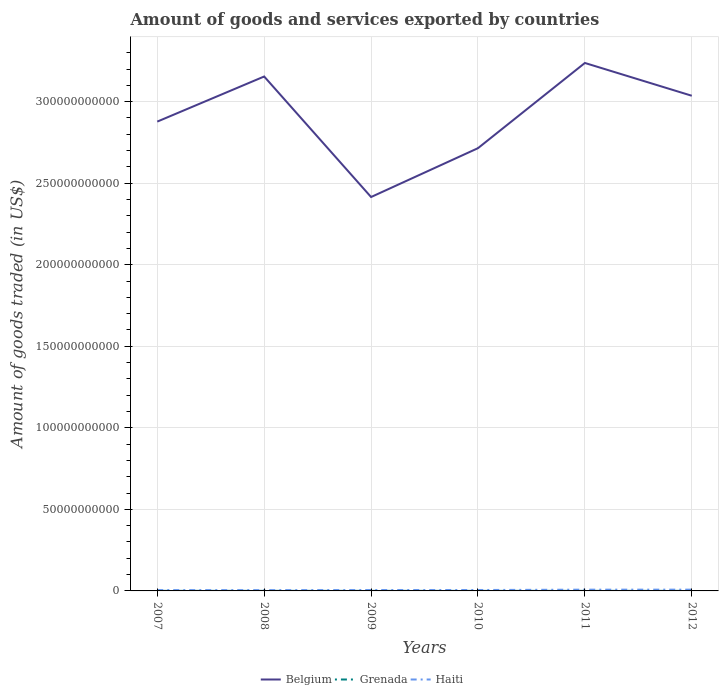How many different coloured lines are there?
Give a very brief answer. 3. Is the number of lines equal to the number of legend labels?
Make the answer very short. Yes. Across all years, what is the maximum total amount of goods and services exported in Grenada?
Provide a short and direct response. 3.11e+07. In which year was the total amount of goods and services exported in Haiti maximum?
Ensure brevity in your answer.  2008. What is the total total amount of goods and services exported in Haiti in the graph?
Your answer should be compact. -2.78e+08. What is the difference between the highest and the second highest total amount of goods and services exported in Belgium?
Offer a terse response. 8.22e+1. What is the difference between the highest and the lowest total amount of goods and services exported in Belgium?
Provide a short and direct response. 3. Is the total amount of goods and services exported in Belgium strictly greater than the total amount of goods and services exported in Grenada over the years?
Ensure brevity in your answer.  No. How many lines are there?
Ensure brevity in your answer.  3. How many years are there in the graph?
Make the answer very short. 6. How many legend labels are there?
Offer a terse response. 3. What is the title of the graph?
Your response must be concise. Amount of goods and services exported by countries. Does "Arab World" appear as one of the legend labels in the graph?
Your response must be concise. No. What is the label or title of the X-axis?
Offer a very short reply. Years. What is the label or title of the Y-axis?
Make the answer very short. Amount of goods traded (in US$). What is the Amount of goods traded (in US$) in Belgium in 2007?
Offer a very short reply. 2.88e+11. What is the Amount of goods traded (in US$) of Grenada in 2007?
Your response must be concise. 4.07e+07. What is the Amount of goods traded (in US$) of Haiti in 2007?
Ensure brevity in your answer.  5.22e+08. What is the Amount of goods traded (in US$) in Belgium in 2008?
Keep it short and to the point. 3.15e+11. What is the Amount of goods traded (in US$) of Grenada in 2008?
Provide a succinct answer. 4.05e+07. What is the Amount of goods traded (in US$) of Haiti in 2008?
Make the answer very short. 4.90e+08. What is the Amount of goods traded (in US$) of Belgium in 2009?
Give a very brief answer. 2.42e+11. What is the Amount of goods traded (in US$) of Grenada in 2009?
Your response must be concise. 3.53e+07. What is the Amount of goods traded (in US$) of Haiti in 2009?
Provide a succinct answer. 5.51e+08. What is the Amount of goods traded (in US$) of Belgium in 2010?
Your response must be concise. 2.71e+11. What is the Amount of goods traded (in US$) of Grenada in 2010?
Offer a terse response. 3.11e+07. What is the Amount of goods traded (in US$) of Haiti in 2010?
Offer a terse response. 5.63e+08. What is the Amount of goods traded (in US$) in Belgium in 2011?
Your answer should be compact. 3.24e+11. What is the Amount of goods traded (in US$) of Grenada in 2011?
Give a very brief answer. 3.72e+07. What is the Amount of goods traded (in US$) in Haiti in 2011?
Offer a very short reply. 7.68e+08. What is the Amount of goods traded (in US$) in Belgium in 2012?
Offer a very short reply. 3.04e+11. What is the Amount of goods traded (in US$) of Grenada in 2012?
Offer a terse response. 4.28e+07. What is the Amount of goods traded (in US$) of Haiti in 2012?
Make the answer very short. 7.79e+08. Across all years, what is the maximum Amount of goods traded (in US$) in Belgium?
Give a very brief answer. 3.24e+11. Across all years, what is the maximum Amount of goods traded (in US$) of Grenada?
Ensure brevity in your answer.  4.28e+07. Across all years, what is the maximum Amount of goods traded (in US$) of Haiti?
Ensure brevity in your answer.  7.79e+08. Across all years, what is the minimum Amount of goods traded (in US$) of Belgium?
Your answer should be compact. 2.42e+11. Across all years, what is the minimum Amount of goods traded (in US$) in Grenada?
Your response must be concise. 3.11e+07. Across all years, what is the minimum Amount of goods traded (in US$) in Haiti?
Provide a short and direct response. 4.90e+08. What is the total Amount of goods traded (in US$) of Belgium in the graph?
Offer a terse response. 1.74e+12. What is the total Amount of goods traded (in US$) in Grenada in the graph?
Your answer should be very brief. 2.28e+08. What is the total Amount of goods traded (in US$) in Haiti in the graph?
Your response must be concise. 3.67e+09. What is the difference between the Amount of goods traded (in US$) of Belgium in 2007 and that in 2008?
Provide a short and direct response. -2.77e+1. What is the difference between the Amount of goods traded (in US$) in Grenada in 2007 and that in 2008?
Your answer should be very brief. 2.65e+05. What is the difference between the Amount of goods traded (in US$) in Haiti in 2007 and that in 2008?
Provide a short and direct response. 3.19e+07. What is the difference between the Amount of goods traded (in US$) in Belgium in 2007 and that in 2009?
Provide a succinct answer. 4.62e+1. What is the difference between the Amount of goods traded (in US$) in Grenada in 2007 and that in 2009?
Provide a short and direct response. 5.44e+06. What is the difference between the Amount of goods traded (in US$) in Haiti in 2007 and that in 2009?
Offer a terse response. -2.89e+07. What is the difference between the Amount of goods traded (in US$) of Belgium in 2007 and that in 2010?
Give a very brief answer. 1.63e+1. What is the difference between the Amount of goods traded (in US$) of Grenada in 2007 and that in 2010?
Your answer should be compact. 9.61e+06. What is the difference between the Amount of goods traded (in US$) in Haiti in 2007 and that in 2010?
Keep it short and to the point. -4.13e+07. What is the difference between the Amount of goods traded (in US$) in Belgium in 2007 and that in 2011?
Give a very brief answer. -3.60e+1. What is the difference between the Amount of goods traded (in US$) of Grenada in 2007 and that in 2011?
Your answer should be compact. 3.58e+06. What is the difference between the Amount of goods traded (in US$) in Haiti in 2007 and that in 2011?
Keep it short and to the point. -2.46e+08. What is the difference between the Amount of goods traded (in US$) of Belgium in 2007 and that in 2012?
Your answer should be compact. -1.59e+1. What is the difference between the Amount of goods traded (in US$) of Grenada in 2007 and that in 2012?
Make the answer very short. -2.08e+06. What is the difference between the Amount of goods traded (in US$) of Haiti in 2007 and that in 2012?
Offer a very short reply. -2.57e+08. What is the difference between the Amount of goods traded (in US$) in Belgium in 2008 and that in 2009?
Keep it short and to the point. 7.39e+1. What is the difference between the Amount of goods traded (in US$) of Grenada in 2008 and that in 2009?
Offer a very short reply. 5.17e+06. What is the difference between the Amount of goods traded (in US$) of Haiti in 2008 and that in 2009?
Provide a succinct answer. -6.08e+07. What is the difference between the Amount of goods traded (in US$) in Belgium in 2008 and that in 2010?
Provide a short and direct response. 4.40e+1. What is the difference between the Amount of goods traded (in US$) of Grenada in 2008 and that in 2010?
Your answer should be compact. 9.34e+06. What is the difference between the Amount of goods traded (in US$) in Haiti in 2008 and that in 2010?
Your response must be concise. -7.32e+07. What is the difference between the Amount of goods traded (in US$) in Belgium in 2008 and that in 2011?
Keep it short and to the point. -8.30e+09. What is the difference between the Amount of goods traded (in US$) of Grenada in 2008 and that in 2011?
Offer a very short reply. 3.31e+06. What is the difference between the Amount of goods traded (in US$) of Haiti in 2008 and that in 2011?
Give a very brief answer. -2.78e+08. What is the difference between the Amount of goods traded (in US$) in Belgium in 2008 and that in 2012?
Make the answer very short. 1.18e+1. What is the difference between the Amount of goods traded (in US$) of Grenada in 2008 and that in 2012?
Give a very brief answer. -2.35e+06. What is the difference between the Amount of goods traded (in US$) in Haiti in 2008 and that in 2012?
Make the answer very short. -2.89e+08. What is the difference between the Amount of goods traded (in US$) of Belgium in 2009 and that in 2010?
Your answer should be compact. -3.00e+1. What is the difference between the Amount of goods traded (in US$) of Grenada in 2009 and that in 2010?
Make the answer very short. 4.17e+06. What is the difference between the Amount of goods traded (in US$) in Haiti in 2009 and that in 2010?
Your answer should be compact. -1.24e+07. What is the difference between the Amount of goods traded (in US$) in Belgium in 2009 and that in 2011?
Your answer should be very brief. -8.22e+1. What is the difference between the Amount of goods traded (in US$) of Grenada in 2009 and that in 2011?
Your response must be concise. -1.86e+06. What is the difference between the Amount of goods traded (in US$) in Haiti in 2009 and that in 2011?
Give a very brief answer. -2.17e+08. What is the difference between the Amount of goods traded (in US$) of Belgium in 2009 and that in 2012?
Provide a short and direct response. -6.21e+1. What is the difference between the Amount of goods traded (in US$) in Grenada in 2009 and that in 2012?
Provide a succinct answer. -7.52e+06. What is the difference between the Amount of goods traded (in US$) in Haiti in 2009 and that in 2012?
Keep it short and to the point. -2.28e+08. What is the difference between the Amount of goods traded (in US$) of Belgium in 2010 and that in 2011?
Offer a terse response. -5.22e+1. What is the difference between the Amount of goods traded (in US$) of Grenada in 2010 and that in 2011?
Your answer should be very brief. -6.03e+06. What is the difference between the Amount of goods traded (in US$) of Haiti in 2010 and that in 2011?
Your answer should be compact. -2.05e+08. What is the difference between the Amount of goods traded (in US$) of Belgium in 2010 and that in 2012?
Your answer should be compact. -3.22e+1. What is the difference between the Amount of goods traded (in US$) in Grenada in 2010 and that in 2012?
Keep it short and to the point. -1.17e+07. What is the difference between the Amount of goods traded (in US$) in Haiti in 2010 and that in 2012?
Provide a short and direct response. -2.15e+08. What is the difference between the Amount of goods traded (in US$) in Belgium in 2011 and that in 2012?
Your answer should be compact. 2.01e+1. What is the difference between the Amount of goods traded (in US$) of Grenada in 2011 and that in 2012?
Your answer should be compact. -5.66e+06. What is the difference between the Amount of goods traded (in US$) in Haiti in 2011 and that in 2012?
Provide a short and direct response. -1.08e+07. What is the difference between the Amount of goods traded (in US$) in Belgium in 2007 and the Amount of goods traded (in US$) in Grenada in 2008?
Keep it short and to the point. 2.88e+11. What is the difference between the Amount of goods traded (in US$) in Belgium in 2007 and the Amount of goods traded (in US$) in Haiti in 2008?
Your answer should be very brief. 2.87e+11. What is the difference between the Amount of goods traded (in US$) of Grenada in 2007 and the Amount of goods traded (in US$) of Haiti in 2008?
Keep it short and to the point. -4.49e+08. What is the difference between the Amount of goods traded (in US$) of Belgium in 2007 and the Amount of goods traded (in US$) of Grenada in 2009?
Your response must be concise. 2.88e+11. What is the difference between the Amount of goods traded (in US$) in Belgium in 2007 and the Amount of goods traded (in US$) in Haiti in 2009?
Keep it short and to the point. 2.87e+11. What is the difference between the Amount of goods traded (in US$) of Grenada in 2007 and the Amount of goods traded (in US$) of Haiti in 2009?
Ensure brevity in your answer.  -5.10e+08. What is the difference between the Amount of goods traded (in US$) of Belgium in 2007 and the Amount of goods traded (in US$) of Grenada in 2010?
Offer a terse response. 2.88e+11. What is the difference between the Amount of goods traded (in US$) in Belgium in 2007 and the Amount of goods traded (in US$) in Haiti in 2010?
Your answer should be very brief. 2.87e+11. What is the difference between the Amount of goods traded (in US$) in Grenada in 2007 and the Amount of goods traded (in US$) in Haiti in 2010?
Ensure brevity in your answer.  -5.23e+08. What is the difference between the Amount of goods traded (in US$) in Belgium in 2007 and the Amount of goods traded (in US$) in Grenada in 2011?
Your answer should be very brief. 2.88e+11. What is the difference between the Amount of goods traded (in US$) in Belgium in 2007 and the Amount of goods traded (in US$) in Haiti in 2011?
Your response must be concise. 2.87e+11. What is the difference between the Amount of goods traded (in US$) in Grenada in 2007 and the Amount of goods traded (in US$) in Haiti in 2011?
Keep it short and to the point. -7.27e+08. What is the difference between the Amount of goods traded (in US$) of Belgium in 2007 and the Amount of goods traded (in US$) of Grenada in 2012?
Your answer should be compact. 2.88e+11. What is the difference between the Amount of goods traded (in US$) of Belgium in 2007 and the Amount of goods traded (in US$) of Haiti in 2012?
Your answer should be very brief. 2.87e+11. What is the difference between the Amount of goods traded (in US$) in Grenada in 2007 and the Amount of goods traded (in US$) in Haiti in 2012?
Ensure brevity in your answer.  -7.38e+08. What is the difference between the Amount of goods traded (in US$) of Belgium in 2008 and the Amount of goods traded (in US$) of Grenada in 2009?
Your answer should be compact. 3.15e+11. What is the difference between the Amount of goods traded (in US$) in Belgium in 2008 and the Amount of goods traded (in US$) in Haiti in 2009?
Give a very brief answer. 3.15e+11. What is the difference between the Amount of goods traded (in US$) in Grenada in 2008 and the Amount of goods traded (in US$) in Haiti in 2009?
Give a very brief answer. -5.11e+08. What is the difference between the Amount of goods traded (in US$) of Belgium in 2008 and the Amount of goods traded (in US$) of Grenada in 2010?
Keep it short and to the point. 3.15e+11. What is the difference between the Amount of goods traded (in US$) of Belgium in 2008 and the Amount of goods traded (in US$) of Haiti in 2010?
Provide a short and direct response. 3.15e+11. What is the difference between the Amount of goods traded (in US$) in Grenada in 2008 and the Amount of goods traded (in US$) in Haiti in 2010?
Provide a succinct answer. -5.23e+08. What is the difference between the Amount of goods traded (in US$) in Belgium in 2008 and the Amount of goods traded (in US$) in Grenada in 2011?
Provide a succinct answer. 3.15e+11. What is the difference between the Amount of goods traded (in US$) in Belgium in 2008 and the Amount of goods traded (in US$) in Haiti in 2011?
Give a very brief answer. 3.15e+11. What is the difference between the Amount of goods traded (in US$) of Grenada in 2008 and the Amount of goods traded (in US$) of Haiti in 2011?
Offer a terse response. -7.28e+08. What is the difference between the Amount of goods traded (in US$) in Belgium in 2008 and the Amount of goods traded (in US$) in Grenada in 2012?
Give a very brief answer. 3.15e+11. What is the difference between the Amount of goods traded (in US$) of Belgium in 2008 and the Amount of goods traded (in US$) of Haiti in 2012?
Provide a short and direct response. 3.15e+11. What is the difference between the Amount of goods traded (in US$) of Grenada in 2008 and the Amount of goods traded (in US$) of Haiti in 2012?
Your answer should be very brief. -7.38e+08. What is the difference between the Amount of goods traded (in US$) of Belgium in 2009 and the Amount of goods traded (in US$) of Grenada in 2010?
Provide a short and direct response. 2.41e+11. What is the difference between the Amount of goods traded (in US$) of Belgium in 2009 and the Amount of goods traded (in US$) of Haiti in 2010?
Offer a very short reply. 2.41e+11. What is the difference between the Amount of goods traded (in US$) in Grenada in 2009 and the Amount of goods traded (in US$) in Haiti in 2010?
Offer a very short reply. -5.28e+08. What is the difference between the Amount of goods traded (in US$) of Belgium in 2009 and the Amount of goods traded (in US$) of Grenada in 2011?
Offer a very short reply. 2.41e+11. What is the difference between the Amount of goods traded (in US$) in Belgium in 2009 and the Amount of goods traded (in US$) in Haiti in 2011?
Your answer should be very brief. 2.41e+11. What is the difference between the Amount of goods traded (in US$) in Grenada in 2009 and the Amount of goods traded (in US$) in Haiti in 2011?
Make the answer very short. -7.33e+08. What is the difference between the Amount of goods traded (in US$) of Belgium in 2009 and the Amount of goods traded (in US$) of Grenada in 2012?
Your response must be concise. 2.41e+11. What is the difference between the Amount of goods traded (in US$) of Belgium in 2009 and the Amount of goods traded (in US$) of Haiti in 2012?
Offer a terse response. 2.41e+11. What is the difference between the Amount of goods traded (in US$) in Grenada in 2009 and the Amount of goods traded (in US$) in Haiti in 2012?
Keep it short and to the point. -7.44e+08. What is the difference between the Amount of goods traded (in US$) in Belgium in 2010 and the Amount of goods traded (in US$) in Grenada in 2011?
Offer a terse response. 2.71e+11. What is the difference between the Amount of goods traded (in US$) of Belgium in 2010 and the Amount of goods traded (in US$) of Haiti in 2011?
Your answer should be compact. 2.71e+11. What is the difference between the Amount of goods traded (in US$) in Grenada in 2010 and the Amount of goods traded (in US$) in Haiti in 2011?
Offer a very short reply. -7.37e+08. What is the difference between the Amount of goods traded (in US$) of Belgium in 2010 and the Amount of goods traded (in US$) of Grenada in 2012?
Ensure brevity in your answer.  2.71e+11. What is the difference between the Amount of goods traded (in US$) in Belgium in 2010 and the Amount of goods traded (in US$) in Haiti in 2012?
Your answer should be compact. 2.71e+11. What is the difference between the Amount of goods traded (in US$) of Grenada in 2010 and the Amount of goods traded (in US$) of Haiti in 2012?
Your answer should be compact. -7.48e+08. What is the difference between the Amount of goods traded (in US$) in Belgium in 2011 and the Amount of goods traded (in US$) in Grenada in 2012?
Offer a terse response. 3.24e+11. What is the difference between the Amount of goods traded (in US$) of Belgium in 2011 and the Amount of goods traded (in US$) of Haiti in 2012?
Your answer should be very brief. 3.23e+11. What is the difference between the Amount of goods traded (in US$) of Grenada in 2011 and the Amount of goods traded (in US$) of Haiti in 2012?
Make the answer very short. -7.42e+08. What is the average Amount of goods traded (in US$) of Belgium per year?
Give a very brief answer. 2.91e+11. What is the average Amount of goods traded (in US$) of Grenada per year?
Keep it short and to the point. 3.79e+07. What is the average Amount of goods traded (in US$) in Haiti per year?
Offer a terse response. 6.12e+08. In the year 2007, what is the difference between the Amount of goods traded (in US$) in Belgium and Amount of goods traded (in US$) in Grenada?
Your response must be concise. 2.88e+11. In the year 2007, what is the difference between the Amount of goods traded (in US$) of Belgium and Amount of goods traded (in US$) of Haiti?
Your answer should be compact. 2.87e+11. In the year 2007, what is the difference between the Amount of goods traded (in US$) of Grenada and Amount of goods traded (in US$) of Haiti?
Ensure brevity in your answer.  -4.81e+08. In the year 2008, what is the difference between the Amount of goods traded (in US$) in Belgium and Amount of goods traded (in US$) in Grenada?
Ensure brevity in your answer.  3.15e+11. In the year 2008, what is the difference between the Amount of goods traded (in US$) of Belgium and Amount of goods traded (in US$) of Haiti?
Your answer should be compact. 3.15e+11. In the year 2008, what is the difference between the Amount of goods traded (in US$) in Grenada and Amount of goods traded (in US$) in Haiti?
Your response must be concise. -4.50e+08. In the year 2009, what is the difference between the Amount of goods traded (in US$) of Belgium and Amount of goods traded (in US$) of Grenada?
Keep it short and to the point. 2.41e+11. In the year 2009, what is the difference between the Amount of goods traded (in US$) in Belgium and Amount of goods traded (in US$) in Haiti?
Offer a terse response. 2.41e+11. In the year 2009, what is the difference between the Amount of goods traded (in US$) in Grenada and Amount of goods traded (in US$) in Haiti?
Keep it short and to the point. -5.16e+08. In the year 2010, what is the difference between the Amount of goods traded (in US$) in Belgium and Amount of goods traded (in US$) in Grenada?
Ensure brevity in your answer.  2.71e+11. In the year 2010, what is the difference between the Amount of goods traded (in US$) in Belgium and Amount of goods traded (in US$) in Haiti?
Provide a succinct answer. 2.71e+11. In the year 2010, what is the difference between the Amount of goods traded (in US$) in Grenada and Amount of goods traded (in US$) in Haiti?
Your answer should be very brief. -5.32e+08. In the year 2011, what is the difference between the Amount of goods traded (in US$) in Belgium and Amount of goods traded (in US$) in Grenada?
Your answer should be compact. 3.24e+11. In the year 2011, what is the difference between the Amount of goods traded (in US$) of Belgium and Amount of goods traded (in US$) of Haiti?
Your answer should be compact. 3.23e+11. In the year 2011, what is the difference between the Amount of goods traded (in US$) of Grenada and Amount of goods traded (in US$) of Haiti?
Provide a short and direct response. -7.31e+08. In the year 2012, what is the difference between the Amount of goods traded (in US$) in Belgium and Amount of goods traded (in US$) in Grenada?
Offer a terse response. 3.04e+11. In the year 2012, what is the difference between the Amount of goods traded (in US$) of Belgium and Amount of goods traded (in US$) of Haiti?
Your response must be concise. 3.03e+11. In the year 2012, what is the difference between the Amount of goods traded (in US$) of Grenada and Amount of goods traded (in US$) of Haiti?
Your answer should be very brief. -7.36e+08. What is the ratio of the Amount of goods traded (in US$) in Belgium in 2007 to that in 2008?
Offer a terse response. 0.91. What is the ratio of the Amount of goods traded (in US$) of Grenada in 2007 to that in 2008?
Your answer should be very brief. 1.01. What is the ratio of the Amount of goods traded (in US$) of Haiti in 2007 to that in 2008?
Give a very brief answer. 1.06. What is the ratio of the Amount of goods traded (in US$) in Belgium in 2007 to that in 2009?
Your answer should be compact. 1.19. What is the ratio of the Amount of goods traded (in US$) in Grenada in 2007 to that in 2009?
Make the answer very short. 1.15. What is the ratio of the Amount of goods traded (in US$) in Haiti in 2007 to that in 2009?
Your answer should be compact. 0.95. What is the ratio of the Amount of goods traded (in US$) in Belgium in 2007 to that in 2010?
Ensure brevity in your answer.  1.06. What is the ratio of the Amount of goods traded (in US$) of Grenada in 2007 to that in 2010?
Keep it short and to the point. 1.31. What is the ratio of the Amount of goods traded (in US$) in Haiti in 2007 to that in 2010?
Your answer should be compact. 0.93. What is the ratio of the Amount of goods traded (in US$) in Belgium in 2007 to that in 2011?
Ensure brevity in your answer.  0.89. What is the ratio of the Amount of goods traded (in US$) in Grenada in 2007 to that in 2011?
Ensure brevity in your answer.  1.1. What is the ratio of the Amount of goods traded (in US$) in Haiti in 2007 to that in 2011?
Offer a very short reply. 0.68. What is the ratio of the Amount of goods traded (in US$) in Belgium in 2007 to that in 2012?
Keep it short and to the point. 0.95. What is the ratio of the Amount of goods traded (in US$) in Grenada in 2007 to that in 2012?
Provide a succinct answer. 0.95. What is the ratio of the Amount of goods traded (in US$) in Haiti in 2007 to that in 2012?
Give a very brief answer. 0.67. What is the ratio of the Amount of goods traded (in US$) of Belgium in 2008 to that in 2009?
Provide a succinct answer. 1.31. What is the ratio of the Amount of goods traded (in US$) in Grenada in 2008 to that in 2009?
Provide a succinct answer. 1.15. What is the ratio of the Amount of goods traded (in US$) in Haiti in 2008 to that in 2009?
Your answer should be very brief. 0.89. What is the ratio of the Amount of goods traded (in US$) in Belgium in 2008 to that in 2010?
Offer a very short reply. 1.16. What is the ratio of the Amount of goods traded (in US$) of Grenada in 2008 to that in 2010?
Your answer should be very brief. 1.3. What is the ratio of the Amount of goods traded (in US$) of Haiti in 2008 to that in 2010?
Offer a terse response. 0.87. What is the ratio of the Amount of goods traded (in US$) in Belgium in 2008 to that in 2011?
Provide a short and direct response. 0.97. What is the ratio of the Amount of goods traded (in US$) in Grenada in 2008 to that in 2011?
Your response must be concise. 1.09. What is the ratio of the Amount of goods traded (in US$) of Haiti in 2008 to that in 2011?
Keep it short and to the point. 0.64. What is the ratio of the Amount of goods traded (in US$) of Belgium in 2008 to that in 2012?
Ensure brevity in your answer.  1.04. What is the ratio of the Amount of goods traded (in US$) of Grenada in 2008 to that in 2012?
Provide a short and direct response. 0.95. What is the ratio of the Amount of goods traded (in US$) in Haiti in 2008 to that in 2012?
Give a very brief answer. 0.63. What is the ratio of the Amount of goods traded (in US$) of Belgium in 2009 to that in 2010?
Provide a short and direct response. 0.89. What is the ratio of the Amount of goods traded (in US$) of Grenada in 2009 to that in 2010?
Your answer should be compact. 1.13. What is the ratio of the Amount of goods traded (in US$) in Haiti in 2009 to that in 2010?
Make the answer very short. 0.98. What is the ratio of the Amount of goods traded (in US$) of Belgium in 2009 to that in 2011?
Ensure brevity in your answer.  0.75. What is the ratio of the Amount of goods traded (in US$) of Grenada in 2009 to that in 2011?
Ensure brevity in your answer.  0.95. What is the ratio of the Amount of goods traded (in US$) in Haiti in 2009 to that in 2011?
Your answer should be very brief. 0.72. What is the ratio of the Amount of goods traded (in US$) in Belgium in 2009 to that in 2012?
Offer a very short reply. 0.8. What is the ratio of the Amount of goods traded (in US$) of Grenada in 2009 to that in 2012?
Keep it short and to the point. 0.82. What is the ratio of the Amount of goods traded (in US$) of Haiti in 2009 to that in 2012?
Provide a short and direct response. 0.71. What is the ratio of the Amount of goods traded (in US$) in Belgium in 2010 to that in 2011?
Ensure brevity in your answer.  0.84. What is the ratio of the Amount of goods traded (in US$) of Grenada in 2010 to that in 2011?
Your response must be concise. 0.84. What is the ratio of the Amount of goods traded (in US$) of Haiti in 2010 to that in 2011?
Give a very brief answer. 0.73. What is the ratio of the Amount of goods traded (in US$) of Belgium in 2010 to that in 2012?
Your answer should be very brief. 0.89. What is the ratio of the Amount of goods traded (in US$) of Grenada in 2010 to that in 2012?
Make the answer very short. 0.73. What is the ratio of the Amount of goods traded (in US$) of Haiti in 2010 to that in 2012?
Your response must be concise. 0.72. What is the ratio of the Amount of goods traded (in US$) of Belgium in 2011 to that in 2012?
Make the answer very short. 1.07. What is the ratio of the Amount of goods traded (in US$) of Grenada in 2011 to that in 2012?
Offer a very short reply. 0.87. What is the ratio of the Amount of goods traded (in US$) in Haiti in 2011 to that in 2012?
Give a very brief answer. 0.99. What is the difference between the highest and the second highest Amount of goods traded (in US$) of Belgium?
Offer a terse response. 8.30e+09. What is the difference between the highest and the second highest Amount of goods traded (in US$) of Grenada?
Keep it short and to the point. 2.08e+06. What is the difference between the highest and the second highest Amount of goods traded (in US$) of Haiti?
Offer a very short reply. 1.08e+07. What is the difference between the highest and the lowest Amount of goods traded (in US$) in Belgium?
Offer a very short reply. 8.22e+1. What is the difference between the highest and the lowest Amount of goods traded (in US$) in Grenada?
Offer a terse response. 1.17e+07. What is the difference between the highest and the lowest Amount of goods traded (in US$) in Haiti?
Offer a terse response. 2.89e+08. 